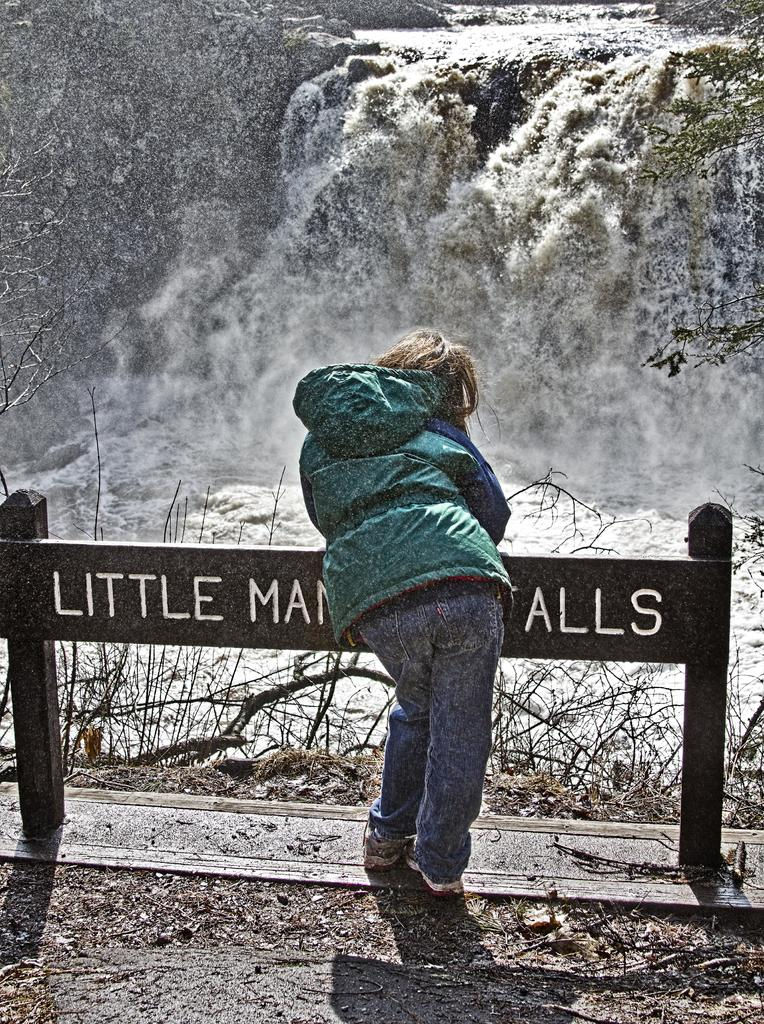What is the main subject of the image? There is a person standing in the image. Can you describe the person's clothing? The person is wearing clothes, including a jacket and shoes. What type of natural feature can be seen in the image? There is a waterfall in the image. What is the ground made of in the image? There is dry grass in the image. What kind of structure is present in the image? There is a board with two poles in the image. How many kitties are sleeping on the beds in the image? There are no beds or kitties present in the image. Is the person standing in the rain in the image? There is no indication of rain in the image; the sky is not visible, and the person is standing on dry grass. 